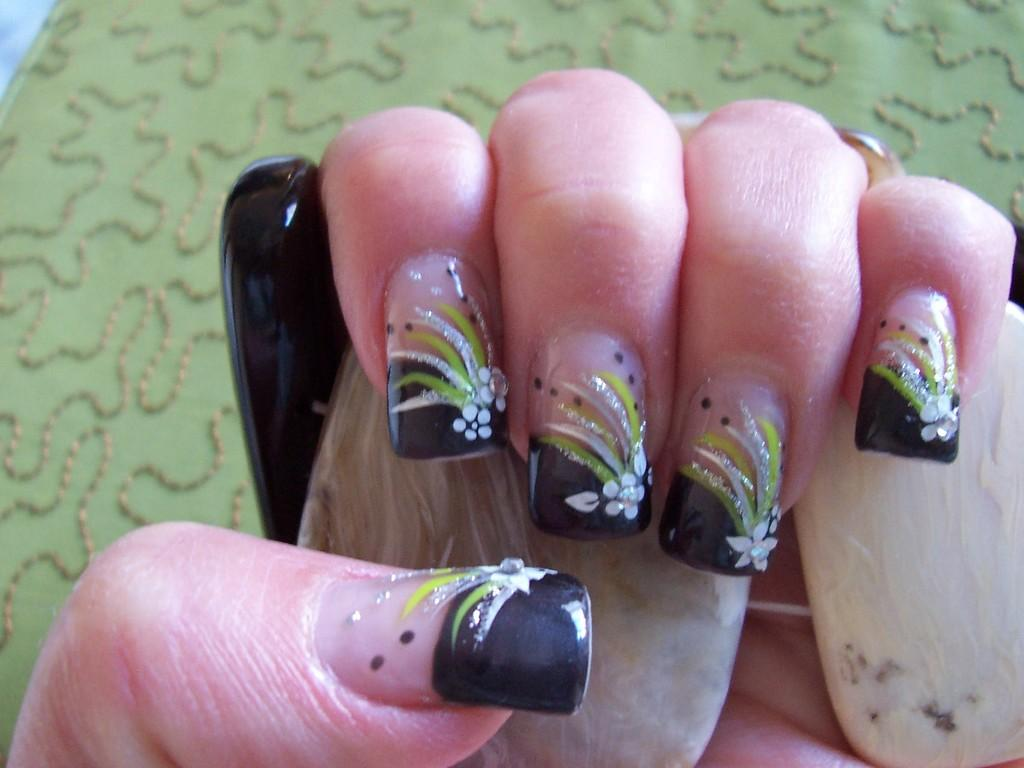What can be seen in the image related to a person's hands? There are a person's fingers with nail art in the image. What is the person holding in the image? The person is holding an object. What can be seen in the background of the image? There is a cloth with a design in the background of the image. What type of trade is being conducted in the image? There is no trade being conducted in the image; it only shows a person's fingers with nail art, an object, and a cloth with a design in the background. 